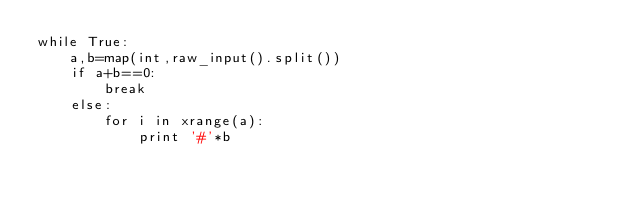Convert code to text. <code><loc_0><loc_0><loc_500><loc_500><_Python_>while True:
	a,b=map(int,raw_input().split())
	if a+b==0:
		break
	else:
		for i in xrange(a):
			print '#'*b</code> 